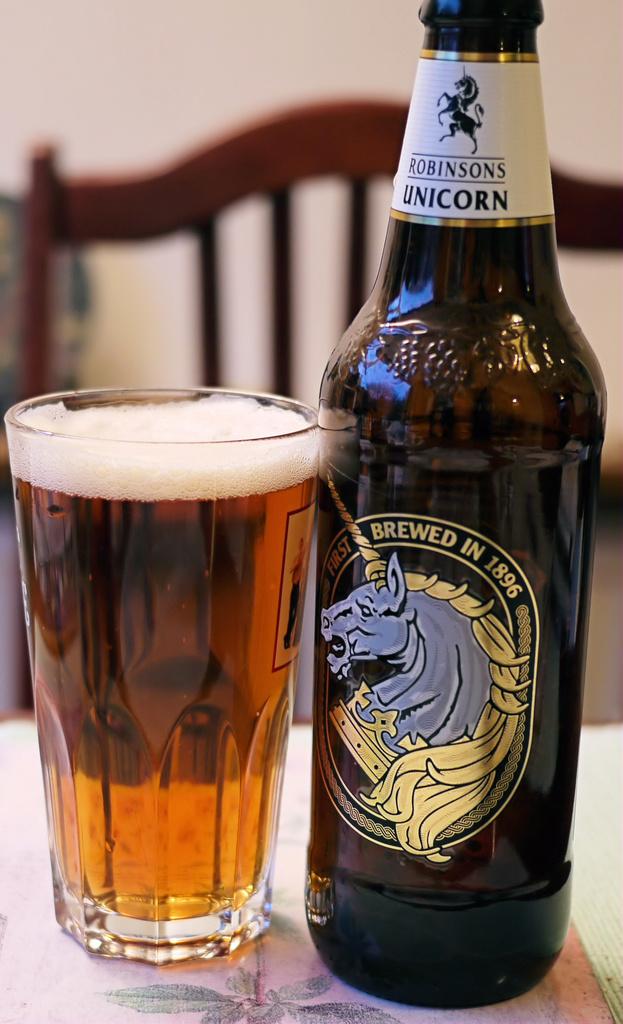What is the brand of this beverage?
Your answer should be compact. Robinson's unicorn. When was this brewed in?
Your answer should be compact. 1896. 